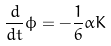<formula> <loc_0><loc_0><loc_500><loc_500>\frac { d } { d t } \phi = - \frac { 1 } { 6 } \alpha K</formula> 